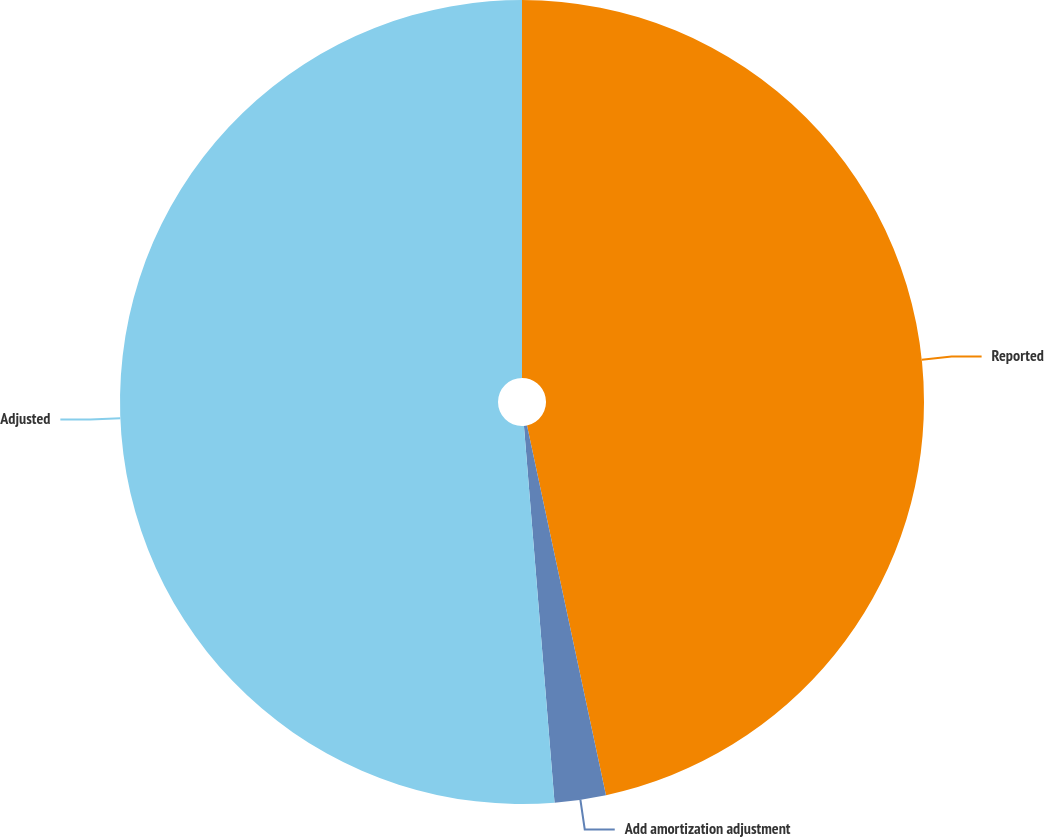Convert chart. <chart><loc_0><loc_0><loc_500><loc_500><pie_chart><fcel>Reported<fcel>Add amortization adjustment<fcel>Adjusted<nl><fcel>46.65%<fcel>2.06%<fcel>51.29%<nl></chart> 